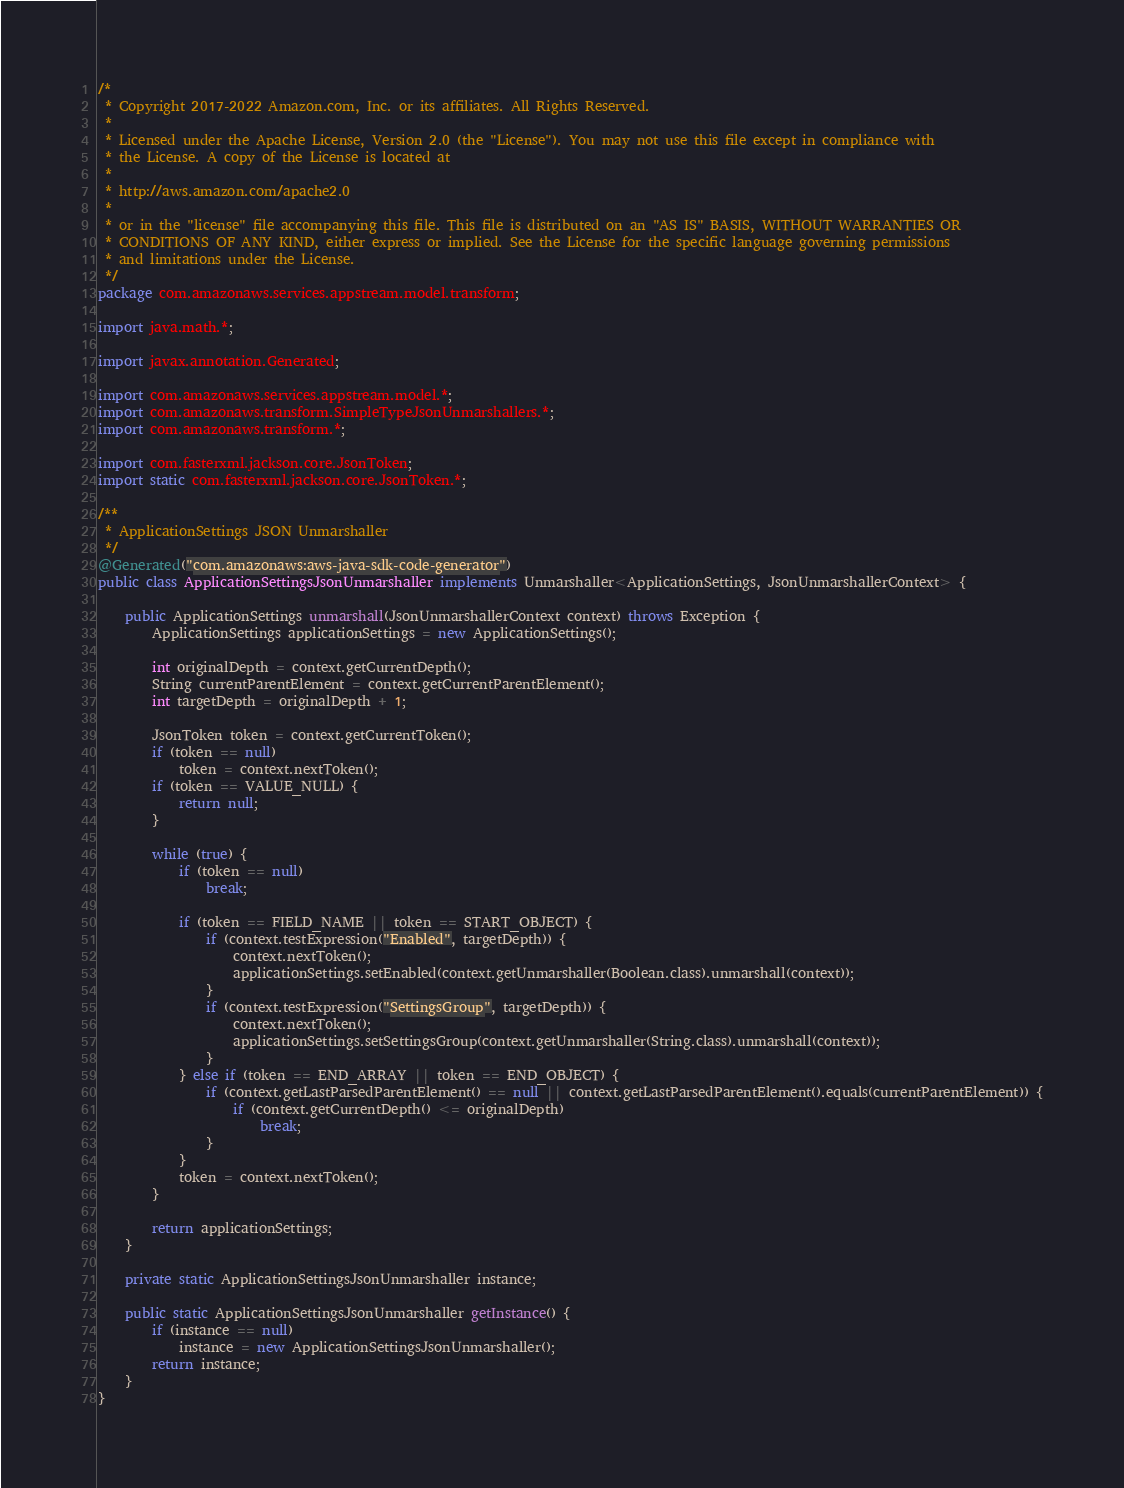<code> <loc_0><loc_0><loc_500><loc_500><_Java_>/*
 * Copyright 2017-2022 Amazon.com, Inc. or its affiliates. All Rights Reserved.
 * 
 * Licensed under the Apache License, Version 2.0 (the "License"). You may not use this file except in compliance with
 * the License. A copy of the License is located at
 * 
 * http://aws.amazon.com/apache2.0
 * 
 * or in the "license" file accompanying this file. This file is distributed on an "AS IS" BASIS, WITHOUT WARRANTIES OR
 * CONDITIONS OF ANY KIND, either express or implied. See the License for the specific language governing permissions
 * and limitations under the License.
 */
package com.amazonaws.services.appstream.model.transform;

import java.math.*;

import javax.annotation.Generated;

import com.amazonaws.services.appstream.model.*;
import com.amazonaws.transform.SimpleTypeJsonUnmarshallers.*;
import com.amazonaws.transform.*;

import com.fasterxml.jackson.core.JsonToken;
import static com.fasterxml.jackson.core.JsonToken.*;

/**
 * ApplicationSettings JSON Unmarshaller
 */
@Generated("com.amazonaws:aws-java-sdk-code-generator")
public class ApplicationSettingsJsonUnmarshaller implements Unmarshaller<ApplicationSettings, JsonUnmarshallerContext> {

    public ApplicationSettings unmarshall(JsonUnmarshallerContext context) throws Exception {
        ApplicationSettings applicationSettings = new ApplicationSettings();

        int originalDepth = context.getCurrentDepth();
        String currentParentElement = context.getCurrentParentElement();
        int targetDepth = originalDepth + 1;

        JsonToken token = context.getCurrentToken();
        if (token == null)
            token = context.nextToken();
        if (token == VALUE_NULL) {
            return null;
        }

        while (true) {
            if (token == null)
                break;

            if (token == FIELD_NAME || token == START_OBJECT) {
                if (context.testExpression("Enabled", targetDepth)) {
                    context.nextToken();
                    applicationSettings.setEnabled(context.getUnmarshaller(Boolean.class).unmarshall(context));
                }
                if (context.testExpression("SettingsGroup", targetDepth)) {
                    context.nextToken();
                    applicationSettings.setSettingsGroup(context.getUnmarshaller(String.class).unmarshall(context));
                }
            } else if (token == END_ARRAY || token == END_OBJECT) {
                if (context.getLastParsedParentElement() == null || context.getLastParsedParentElement().equals(currentParentElement)) {
                    if (context.getCurrentDepth() <= originalDepth)
                        break;
                }
            }
            token = context.nextToken();
        }

        return applicationSettings;
    }

    private static ApplicationSettingsJsonUnmarshaller instance;

    public static ApplicationSettingsJsonUnmarshaller getInstance() {
        if (instance == null)
            instance = new ApplicationSettingsJsonUnmarshaller();
        return instance;
    }
}
</code> 